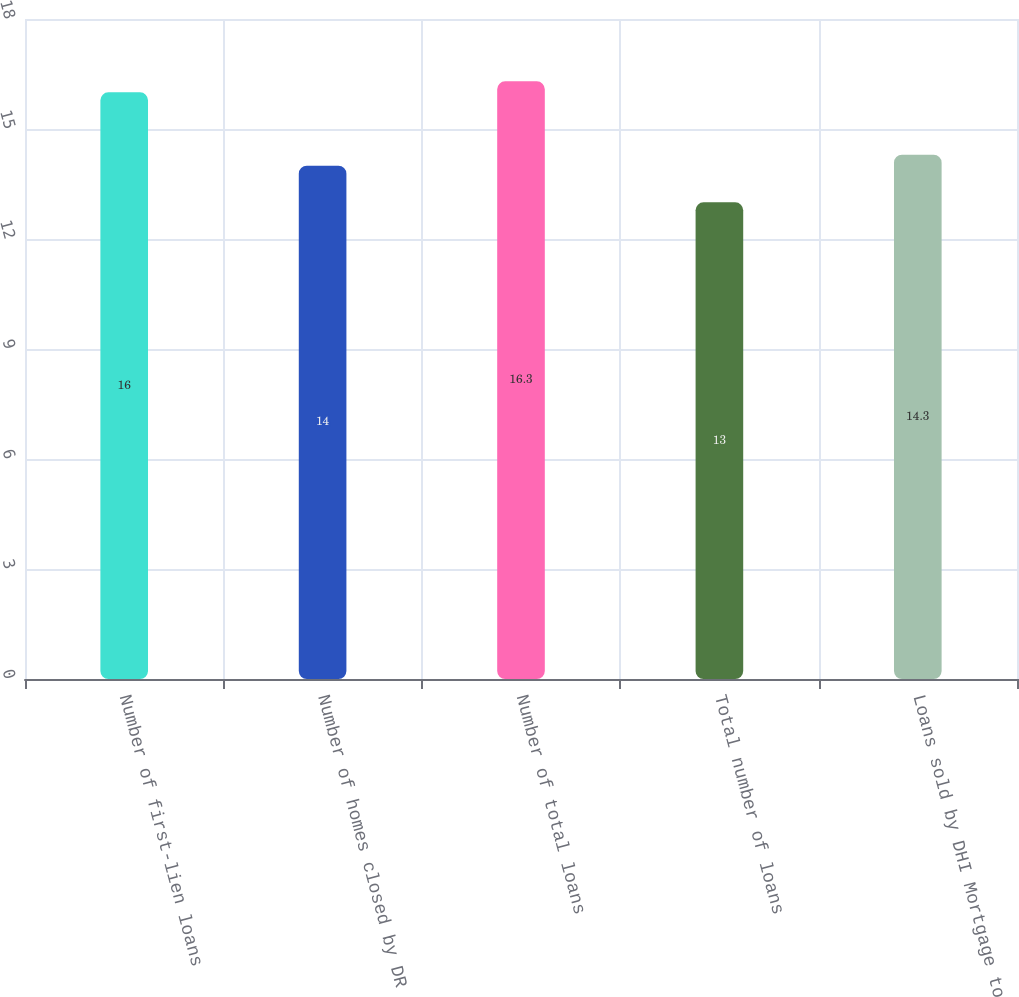Convert chart to OTSL. <chart><loc_0><loc_0><loc_500><loc_500><bar_chart><fcel>Number of first-lien loans<fcel>Number of homes closed by DR<fcel>Number of total loans<fcel>Total number of loans<fcel>Loans sold by DHI Mortgage to<nl><fcel>16<fcel>14<fcel>16.3<fcel>13<fcel>14.3<nl></chart> 